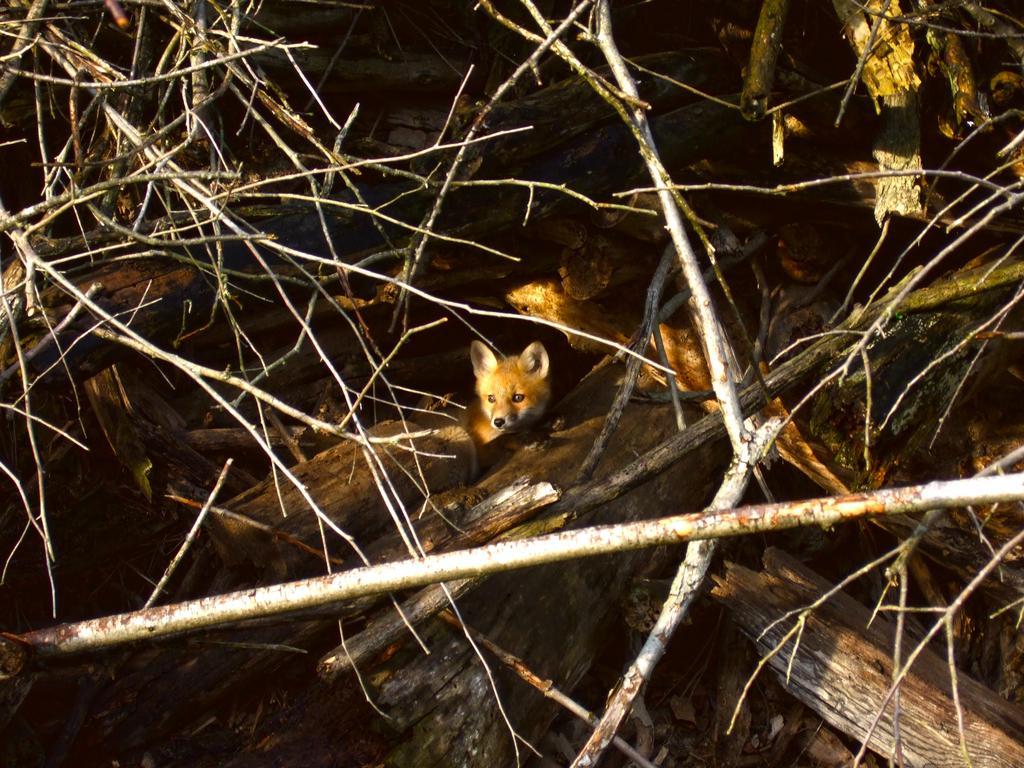In one or two sentences, can you explain what this image depicts? In this picture we can see some sticks and wood, there is an animal here. 